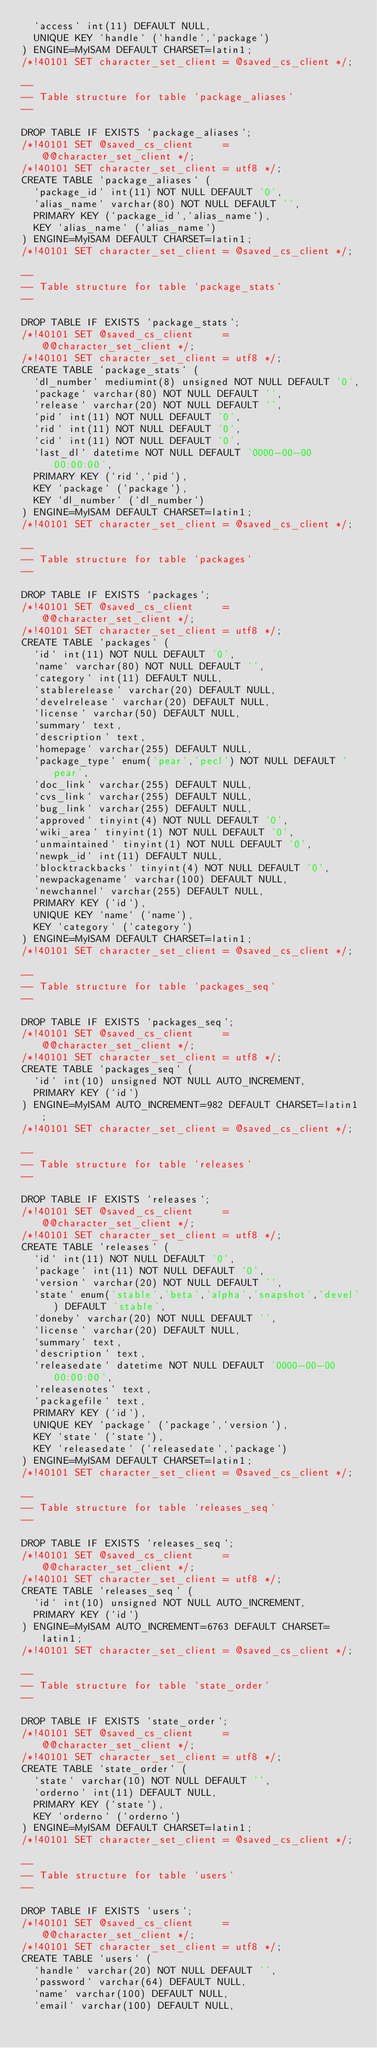Convert code to text. <code><loc_0><loc_0><loc_500><loc_500><_SQL_>  `access` int(11) DEFAULT NULL,
  UNIQUE KEY `handle` (`handle`,`package`)
) ENGINE=MyISAM DEFAULT CHARSET=latin1;
/*!40101 SET character_set_client = @saved_cs_client */;

--
-- Table structure for table `package_aliases`
--

DROP TABLE IF EXISTS `package_aliases`;
/*!40101 SET @saved_cs_client     = @@character_set_client */;
/*!40101 SET character_set_client = utf8 */;
CREATE TABLE `package_aliases` (
  `package_id` int(11) NOT NULL DEFAULT '0',
  `alias_name` varchar(80) NOT NULL DEFAULT '',
  PRIMARY KEY (`package_id`,`alias_name`),
  KEY `alias_name` (`alias_name`)
) ENGINE=MyISAM DEFAULT CHARSET=latin1;
/*!40101 SET character_set_client = @saved_cs_client */;

--
-- Table structure for table `package_stats`
--

DROP TABLE IF EXISTS `package_stats`;
/*!40101 SET @saved_cs_client     = @@character_set_client */;
/*!40101 SET character_set_client = utf8 */;
CREATE TABLE `package_stats` (
  `dl_number` mediumint(8) unsigned NOT NULL DEFAULT '0',
  `package` varchar(80) NOT NULL DEFAULT '',
  `release` varchar(20) NOT NULL DEFAULT '',
  `pid` int(11) NOT NULL DEFAULT '0',
  `rid` int(11) NOT NULL DEFAULT '0',
  `cid` int(11) NOT NULL DEFAULT '0',
  `last_dl` datetime NOT NULL DEFAULT '0000-00-00 00:00:00',
  PRIMARY KEY (`rid`,`pid`),
  KEY `package` (`package`),
  KEY `dl_number` (`dl_number`)
) ENGINE=MyISAM DEFAULT CHARSET=latin1;
/*!40101 SET character_set_client = @saved_cs_client */;

--
-- Table structure for table `packages`
--

DROP TABLE IF EXISTS `packages`;
/*!40101 SET @saved_cs_client     = @@character_set_client */;
/*!40101 SET character_set_client = utf8 */;
CREATE TABLE `packages` (
  `id` int(11) NOT NULL DEFAULT '0',
  `name` varchar(80) NOT NULL DEFAULT '',
  `category` int(11) DEFAULT NULL,
  `stablerelease` varchar(20) DEFAULT NULL,
  `develrelease` varchar(20) DEFAULT NULL,
  `license` varchar(50) DEFAULT NULL,
  `summary` text,
  `description` text,
  `homepage` varchar(255) DEFAULT NULL,
  `package_type` enum('pear','pecl') NOT NULL DEFAULT 'pear',
  `doc_link` varchar(255) DEFAULT NULL,
  `cvs_link` varchar(255) DEFAULT NULL,
  `bug_link` varchar(255) DEFAULT NULL,
  `approved` tinyint(4) NOT NULL DEFAULT '0',
  `wiki_area` tinyint(1) NOT NULL DEFAULT '0',
  `unmaintained` tinyint(1) NOT NULL DEFAULT '0',
  `newpk_id` int(11) DEFAULT NULL,
  `blocktrackbacks` tinyint(4) NOT NULL DEFAULT '0',
  `newpackagename` varchar(100) DEFAULT NULL,
  `newchannel` varchar(255) DEFAULT NULL,
  PRIMARY KEY (`id`),
  UNIQUE KEY `name` (`name`),
  KEY `category` (`category`)
) ENGINE=MyISAM DEFAULT CHARSET=latin1;
/*!40101 SET character_set_client = @saved_cs_client */;

--
-- Table structure for table `packages_seq`
--

DROP TABLE IF EXISTS `packages_seq`;
/*!40101 SET @saved_cs_client     = @@character_set_client */;
/*!40101 SET character_set_client = utf8 */;
CREATE TABLE `packages_seq` (
  `id` int(10) unsigned NOT NULL AUTO_INCREMENT,
  PRIMARY KEY (`id`)
) ENGINE=MyISAM AUTO_INCREMENT=982 DEFAULT CHARSET=latin1;
/*!40101 SET character_set_client = @saved_cs_client */;

--
-- Table structure for table `releases`
--

DROP TABLE IF EXISTS `releases`;
/*!40101 SET @saved_cs_client     = @@character_set_client */;
/*!40101 SET character_set_client = utf8 */;
CREATE TABLE `releases` (
  `id` int(11) NOT NULL DEFAULT '0',
  `package` int(11) NOT NULL DEFAULT '0',
  `version` varchar(20) NOT NULL DEFAULT '',
  `state` enum('stable','beta','alpha','snapshot','devel') DEFAULT 'stable',
  `doneby` varchar(20) NOT NULL DEFAULT '',
  `license` varchar(20) DEFAULT NULL,
  `summary` text,
  `description` text,
  `releasedate` datetime NOT NULL DEFAULT '0000-00-00 00:00:00',
  `releasenotes` text,
  `packagefile` text,
  PRIMARY KEY (`id`),
  UNIQUE KEY `package` (`package`,`version`),
  KEY `state` (`state`),
  KEY `releasedate` (`releasedate`,`package`)
) ENGINE=MyISAM DEFAULT CHARSET=latin1;
/*!40101 SET character_set_client = @saved_cs_client */;

--
-- Table structure for table `releases_seq`
--

DROP TABLE IF EXISTS `releases_seq`;
/*!40101 SET @saved_cs_client     = @@character_set_client */;
/*!40101 SET character_set_client = utf8 */;
CREATE TABLE `releases_seq` (
  `id` int(10) unsigned NOT NULL AUTO_INCREMENT,
  PRIMARY KEY (`id`)
) ENGINE=MyISAM AUTO_INCREMENT=6763 DEFAULT CHARSET=latin1;
/*!40101 SET character_set_client = @saved_cs_client */;

--
-- Table structure for table `state_order`
--

DROP TABLE IF EXISTS `state_order`;
/*!40101 SET @saved_cs_client     = @@character_set_client */;
/*!40101 SET character_set_client = utf8 */;
CREATE TABLE `state_order` (
  `state` varchar(10) NOT NULL DEFAULT '',
  `orderno` int(11) DEFAULT NULL,
  PRIMARY KEY (`state`),
  KEY `orderno` (`orderno`)
) ENGINE=MyISAM DEFAULT CHARSET=latin1;
/*!40101 SET character_set_client = @saved_cs_client */;

--
-- Table structure for table `users`
--

DROP TABLE IF EXISTS `users`;
/*!40101 SET @saved_cs_client     = @@character_set_client */;
/*!40101 SET character_set_client = utf8 */;
CREATE TABLE `users` (
  `handle` varchar(20) NOT NULL DEFAULT '',
  `password` varchar(64) DEFAULT NULL,
  `name` varchar(100) DEFAULT NULL,
  `email` varchar(100) DEFAULT NULL,</code> 